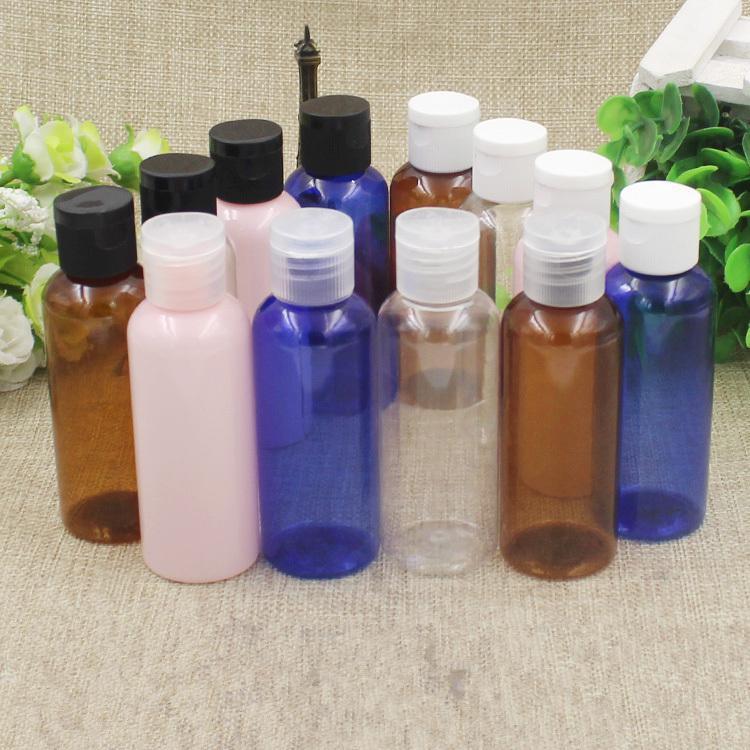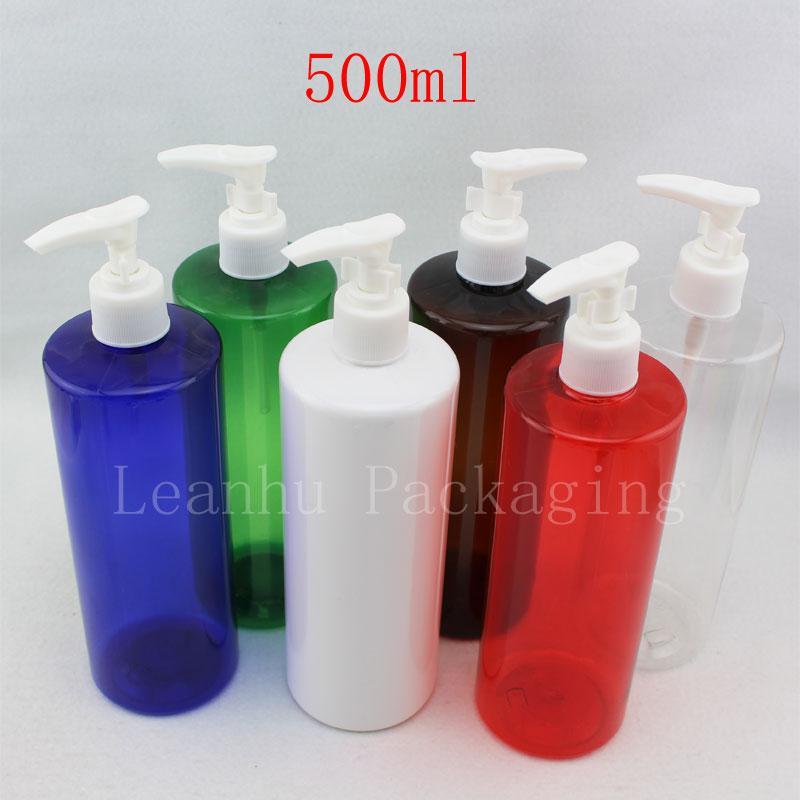The first image is the image on the left, the second image is the image on the right. Given the left and right images, does the statement "The bottles in the image on the left are stacked in a tiered display." hold true? Answer yes or no. No. 